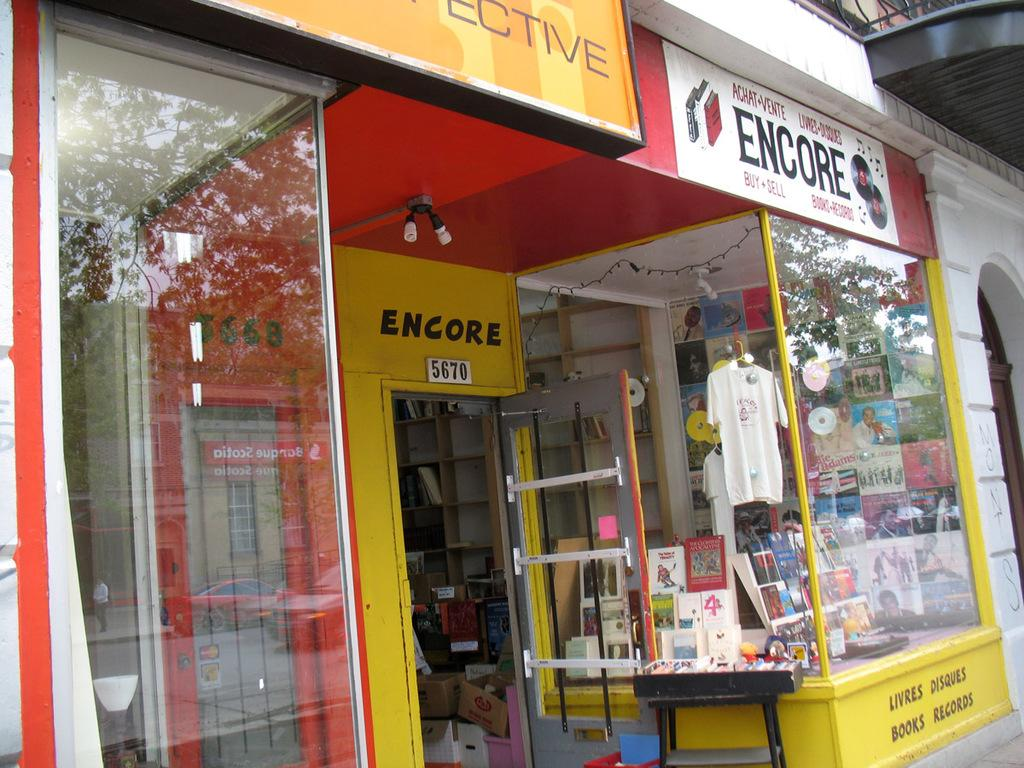<image>
Describe the image concisely. A yellow and red store front with a sign that says Encore 